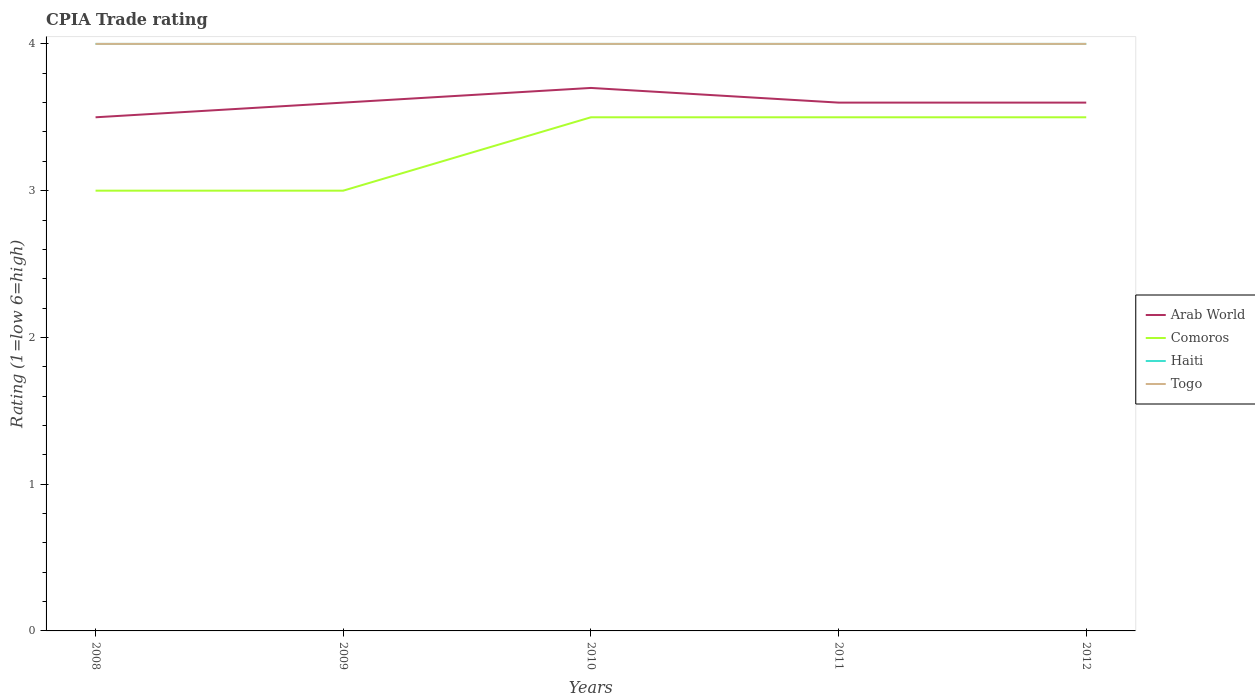How many different coloured lines are there?
Your response must be concise. 4. Across all years, what is the maximum CPIA rating in Arab World?
Your answer should be very brief. 3.5. In which year was the CPIA rating in Arab World maximum?
Ensure brevity in your answer.  2008. What is the difference between the highest and the second highest CPIA rating in Arab World?
Offer a very short reply. 0.2. What is the difference between the highest and the lowest CPIA rating in Haiti?
Your response must be concise. 0. Is the CPIA rating in Haiti strictly greater than the CPIA rating in Arab World over the years?
Give a very brief answer. No. How many years are there in the graph?
Give a very brief answer. 5. What is the difference between two consecutive major ticks on the Y-axis?
Provide a short and direct response. 1. Are the values on the major ticks of Y-axis written in scientific E-notation?
Give a very brief answer. No. Does the graph contain any zero values?
Ensure brevity in your answer.  No. Where does the legend appear in the graph?
Provide a succinct answer. Center right. How many legend labels are there?
Ensure brevity in your answer.  4. What is the title of the graph?
Provide a succinct answer. CPIA Trade rating. What is the Rating (1=low 6=high) in Comoros in 2008?
Ensure brevity in your answer.  3. What is the Rating (1=low 6=high) in Haiti in 2008?
Offer a terse response. 4. What is the Rating (1=low 6=high) in Togo in 2008?
Offer a terse response. 4. What is the Rating (1=low 6=high) in Comoros in 2009?
Ensure brevity in your answer.  3. What is the Rating (1=low 6=high) in Haiti in 2009?
Your answer should be compact. 4. What is the Rating (1=low 6=high) in Togo in 2009?
Your answer should be compact. 4. What is the Rating (1=low 6=high) in Haiti in 2010?
Make the answer very short. 4. What is the Rating (1=low 6=high) of Togo in 2010?
Your answer should be compact. 4. What is the Rating (1=low 6=high) of Arab World in 2011?
Your response must be concise. 3.6. What is the Rating (1=low 6=high) in Comoros in 2011?
Give a very brief answer. 3.5. What is the Rating (1=low 6=high) of Haiti in 2011?
Provide a succinct answer. 4. What is the Rating (1=low 6=high) in Togo in 2011?
Provide a succinct answer. 4. What is the Rating (1=low 6=high) in Haiti in 2012?
Offer a very short reply. 4. What is the Rating (1=low 6=high) of Togo in 2012?
Your response must be concise. 4. Across all years, what is the maximum Rating (1=low 6=high) in Arab World?
Your answer should be very brief. 3.7. Across all years, what is the maximum Rating (1=low 6=high) of Comoros?
Ensure brevity in your answer.  3.5. Across all years, what is the minimum Rating (1=low 6=high) of Arab World?
Provide a short and direct response. 3.5. Across all years, what is the minimum Rating (1=low 6=high) in Haiti?
Provide a short and direct response. 4. What is the total Rating (1=low 6=high) of Comoros in the graph?
Give a very brief answer. 16.5. What is the total Rating (1=low 6=high) of Haiti in the graph?
Offer a very short reply. 20. What is the difference between the Rating (1=low 6=high) of Haiti in 2008 and that in 2009?
Offer a very short reply. 0. What is the difference between the Rating (1=low 6=high) of Togo in 2008 and that in 2009?
Offer a terse response. 0. What is the difference between the Rating (1=low 6=high) of Arab World in 2008 and that in 2010?
Offer a very short reply. -0.2. What is the difference between the Rating (1=low 6=high) of Arab World in 2008 and that in 2011?
Your answer should be compact. -0.1. What is the difference between the Rating (1=low 6=high) of Comoros in 2008 and that in 2011?
Make the answer very short. -0.5. What is the difference between the Rating (1=low 6=high) in Arab World in 2008 and that in 2012?
Keep it short and to the point. -0.1. What is the difference between the Rating (1=low 6=high) of Haiti in 2008 and that in 2012?
Keep it short and to the point. 0. What is the difference between the Rating (1=low 6=high) of Togo in 2008 and that in 2012?
Your response must be concise. 0. What is the difference between the Rating (1=low 6=high) of Haiti in 2009 and that in 2011?
Your answer should be very brief. 0. What is the difference between the Rating (1=low 6=high) of Togo in 2009 and that in 2011?
Provide a short and direct response. 0. What is the difference between the Rating (1=low 6=high) of Comoros in 2009 and that in 2012?
Offer a very short reply. -0.5. What is the difference between the Rating (1=low 6=high) of Haiti in 2009 and that in 2012?
Give a very brief answer. 0. What is the difference between the Rating (1=low 6=high) in Togo in 2009 and that in 2012?
Give a very brief answer. 0. What is the difference between the Rating (1=low 6=high) in Comoros in 2010 and that in 2011?
Make the answer very short. 0. What is the difference between the Rating (1=low 6=high) in Togo in 2010 and that in 2011?
Give a very brief answer. 0. What is the difference between the Rating (1=low 6=high) of Arab World in 2010 and that in 2012?
Offer a very short reply. 0.1. What is the difference between the Rating (1=low 6=high) in Haiti in 2010 and that in 2012?
Your answer should be very brief. 0. What is the difference between the Rating (1=low 6=high) of Comoros in 2011 and that in 2012?
Give a very brief answer. 0. What is the difference between the Rating (1=low 6=high) in Haiti in 2011 and that in 2012?
Keep it short and to the point. 0. What is the difference between the Rating (1=low 6=high) in Arab World in 2008 and the Rating (1=low 6=high) in Comoros in 2009?
Your answer should be very brief. 0.5. What is the difference between the Rating (1=low 6=high) of Arab World in 2008 and the Rating (1=low 6=high) of Togo in 2009?
Your answer should be very brief. -0.5. What is the difference between the Rating (1=low 6=high) in Comoros in 2008 and the Rating (1=low 6=high) in Togo in 2009?
Give a very brief answer. -1. What is the difference between the Rating (1=low 6=high) in Arab World in 2008 and the Rating (1=low 6=high) in Haiti in 2010?
Your answer should be very brief. -0.5. What is the difference between the Rating (1=low 6=high) in Haiti in 2008 and the Rating (1=low 6=high) in Togo in 2010?
Your response must be concise. 0. What is the difference between the Rating (1=low 6=high) of Arab World in 2008 and the Rating (1=low 6=high) of Haiti in 2011?
Make the answer very short. -0.5. What is the difference between the Rating (1=low 6=high) of Comoros in 2008 and the Rating (1=low 6=high) of Haiti in 2011?
Provide a short and direct response. -1. What is the difference between the Rating (1=low 6=high) of Comoros in 2008 and the Rating (1=low 6=high) of Togo in 2011?
Your response must be concise. -1. What is the difference between the Rating (1=low 6=high) of Arab World in 2008 and the Rating (1=low 6=high) of Comoros in 2012?
Your answer should be compact. 0. What is the difference between the Rating (1=low 6=high) in Comoros in 2008 and the Rating (1=low 6=high) in Haiti in 2012?
Make the answer very short. -1. What is the difference between the Rating (1=low 6=high) of Comoros in 2008 and the Rating (1=low 6=high) of Togo in 2012?
Offer a very short reply. -1. What is the difference between the Rating (1=low 6=high) in Haiti in 2008 and the Rating (1=low 6=high) in Togo in 2012?
Ensure brevity in your answer.  0. What is the difference between the Rating (1=low 6=high) of Arab World in 2009 and the Rating (1=low 6=high) of Togo in 2010?
Give a very brief answer. -0.4. What is the difference between the Rating (1=low 6=high) in Comoros in 2009 and the Rating (1=low 6=high) in Togo in 2010?
Offer a very short reply. -1. What is the difference between the Rating (1=low 6=high) of Arab World in 2009 and the Rating (1=low 6=high) of Comoros in 2011?
Your answer should be very brief. 0.1. What is the difference between the Rating (1=low 6=high) in Arab World in 2009 and the Rating (1=low 6=high) in Togo in 2011?
Ensure brevity in your answer.  -0.4. What is the difference between the Rating (1=low 6=high) of Comoros in 2009 and the Rating (1=low 6=high) of Haiti in 2011?
Provide a succinct answer. -1. What is the difference between the Rating (1=low 6=high) in Comoros in 2009 and the Rating (1=low 6=high) in Togo in 2011?
Your response must be concise. -1. What is the difference between the Rating (1=low 6=high) of Haiti in 2009 and the Rating (1=low 6=high) of Togo in 2011?
Your answer should be very brief. 0. What is the difference between the Rating (1=low 6=high) in Arab World in 2009 and the Rating (1=low 6=high) in Comoros in 2012?
Provide a short and direct response. 0.1. What is the difference between the Rating (1=low 6=high) in Arab World in 2009 and the Rating (1=low 6=high) in Togo in 2012?
Your answer should be compact. -0.4. What is the difference between the Rating (1=low 6=high) in Comoros in 2009 and the Rating (1=low 6=high) in Haiti in 2012?
Give a very brief answer. -1. What is the difference between the Rating (1=low 6=high) in Arab World in 2010 and the Rating (1=low 6=high) in Comoros in 2011?
Ensure brevity in your answer.  0.2. What is the difference between the Rating (1=low 6=high) in Arab World in 2010 and the Rating (1=low 6=high) in Togo in 2012?
Your answer should be compact. -0.3. What is the difference between the Rating (1=low 6=high) of Comoros in 2010 and the Rating (1=low 6=high) of Haiti in 2012?
Offer a terse response. -0.5. What is the difference between the Rating (1=low 6=high) of Comoros in 2010 and the Rating (1=low 6=high) of Togo in 2012?
Your answer should be compact. -0.5. What is the difference between the Rating (1=low 6=high) of Haiti in 2010 and the Rating (1=low 6=high) of Togo in 2012?
Offer a terse response. 0. What is the difference between the Rating (1=low 6=high) of Comoros in 2011 and the Rating (1=low 6=high) of Haiti in 2012?
Offer a terse response. -0.5. What is the difference between the Rating (1=low 6=high) of Comoros in 2011 and the Rating (1=low 6=high) of Togo in 2012?
Your answer should be very brief. -0.5. What is the average Rating (1=low 6=high) in Comoros per year?
Your answer should be very brief. 3.3. What is the average Rating (1=low 6=high) of Togo per year?
Give a very brief answer. 4. In the year 2008, what is the difference between the Rating (1=low 6=high) in Arab World and Rating (1=low 6=high) in Comoros?
Make the answer very short. 0.5. In the year 2008, what is the difference between the Rating (1=low 6=high) in Arab World and Rating (1=low 6=high) in Haiti?
Your answer should be very brief. -0.5. In the year 2008, what is the difference between the Rating (1=low 6=high) of Arab World and Rating (1=low 6=high) of Togo?
Make the answer very short. -0.5. In the year 2008, what is the difference between the Rating (1=low 6=high) of Haiti and Rating (1=low 6=high) of Togo?
Ensure brevity in your answer.  0. In the year 2009, what is the difference between the Rating (1=low 6=high) of Arab World and Rating (1=low 6=high) of Haiti?
Your response must be concise. -0.4. In the year 2009, what is the difference between the Rating (1=low 6=high) in Comoros and Rating (1=low 6=high) in Haiti?
Offer a very short reply. -1. In the year 2009, what is the difference between the Rating (1=low 6=high) in Comoros and Rating (1=low 6=high) in Togo?
Provide a succinct answer. -1. In the year 2010, what is the difference between the Rating (1=low 6=high) of Arab World and Rating (1=low 6=high) of Comoros?
Offer a terse response. 0.2. In the year 2010, what is the difference between the Rating (1=low 6=high) in Arab World and Rating (1=low 6=high) in Togo?
Offer a terse response. -0.3. In the year 2010, what is the difference between the Rating (1=low 6=high) of Comoros and Rating (1=low 6=high) of Togo?
Provide a succinct answer. -0.5. In the year 2011, what is the difference between the Rating (1=low 6=high) in Arab World and Rating (1=low 6=high) in Togo?
Keep it short and to the point. -0.4. In the year 2011, what is the difference between the Rating (1=low 6=high) of Haiti and Rating (1=low 6=high) of Togo?
Your response must be concise. 0. In the year 2012, what is the difference between the Rating (1=low 6=high) of Arab World and Rating (1=low 6=high) of Comoros?
Keep it short and to the point. 0.1. In the year 2012, what is the difference between the Rating (1=low 6=high) in Arab World and Rating (1=low 6=high) in Haiti?
Provide a succinct answer. -0.4. In the year 2012, what is the difference between the Rating (1=low 6=high) in Comoros and Rating (1=low 6=high) in Haiti?
Ensure brevity in your answer.  -0.5. In the year 2012, what is the difference between the Rating (1=low 6=high) in Haiti and Rating (1=low 6=high) in Togo?
Give a very brief answer. 0. What is the ratio of the Rating (1=low 6=high) of Arab World in 2008 to that in 2009?
Offer a very short reply. 0.97. What is the ratio of the Rating (1=low 6=high) in Comoros in 2008 to that in 2009?
Give a very brief answer. 1. What is the ratio of the Rating (1=low 6=high) in Haiti in 2008 to that in 2009?
Your response must be concise. 1. What is the ratio of the Rating (1=low 6=high) in Arab World in 2008 to that in 2010?
Offer a very short reply. 0.95. What is the ratio of the Rating (1=low 6=high) in Haiti in 2008 to that in 2010?
Make the answer very short. 1. What is the ratio of the Rating (1=low 6=high) in Arab World in 2008 to that in 2011?
Your response must be concise. 0.97. What is the ratio of the Rating (1=low 6=high) of Arab World in 2008 to that in 2012?
Keep it short and to the point. 0.97. What is the ratio of the Rating (1=low 6=high) in Comoros in 2008 to that in 2012?
Offer a very short reply. 0.86. What is the ratio of the Rating (1=low 6=high) of Haiti in 2008 to that in 2012?
Provide a succinct answer. 1. What is the ratio of the Rating (1=low 6=high) in Togo in 2008 to that in 2012?
Provide a succinct answer. 1. What is the ratio of the Rating (1=low 6=high) in Comoros in 2009 to that in 2010?
Your answer should be compact. 0.86. What is the ratio of the Rating (1=low 6=high) of Haiti in 2009 to that in 2010?
Make the answer very short. 1. What is the ratio of the Rating (1=low 6=high) of Togo in 2009 to that in 2010?
Provide a succinct answer. 1. What is the ratio of the Rating (1=low 6=high) of Togo in 2009 to that in 2011?
Keep it short and to the point. 1. What is the ratio of the Rating (1=low 6=high) of Togo in 2009 to that in 2012?
Your answer should be very brief. 1. What is the ratio of the Rating (1=low 6=high) in Arab World in 2010 to that in 2011?
Your response must be concise. 1.03. What is the ratio of the Rating (1=low 6=high) in Comoros in 2010 to that in 2011?
Your answer should be compact. 1. What is the ratio of the Rating (1=low 6=high) in Togo in 2010 to that in 2011?
Ensure brevity in your answer.  1. What is the ratio of the Rating (1=low 6=high) of Arab World in 2010 to that in 2012?
Make the answer very short. 1.03. What is the ratio of the Rating (1=low 6=high) in Comoros in 2010 to that in 2012?
Provide a succinct answer. 1. What is the ratio of the Rating (1=low 6=high) in Haiti in 2010 to that in 2012?
Offer a very short reply. 1. What is the ratio of the Rating (1=low 6=high) in Togo in 2010 to that in 2012?
Your answer should be compact. 1. What is the ratio of the Rating (1=low 6=high) in Arab World in 2011 to that in 2012?
Make the answer very short. 1. What is the ratio of the Rating (1=low 6=high) in Togo in 2011 to that in 2012?
Ensure brevity in your answer.  1. What is the difference between the highest and the second highest Rating (1=low 6=high) of Arab World?
Provide a succinct answer. 0.1. What is the difference between the highest and the second highest Rating (1=low 6=high) of Comoros?
Your response must be concise. 0. What is the difference between the highest and the second highest Rating (1=low 6=high) of Haiti?
Your answer should be very brief. 0. What is the difference between the highest and the lowest Rating (1=low 6=high) in Togo?
Ensure brevity in your answer.  0. 